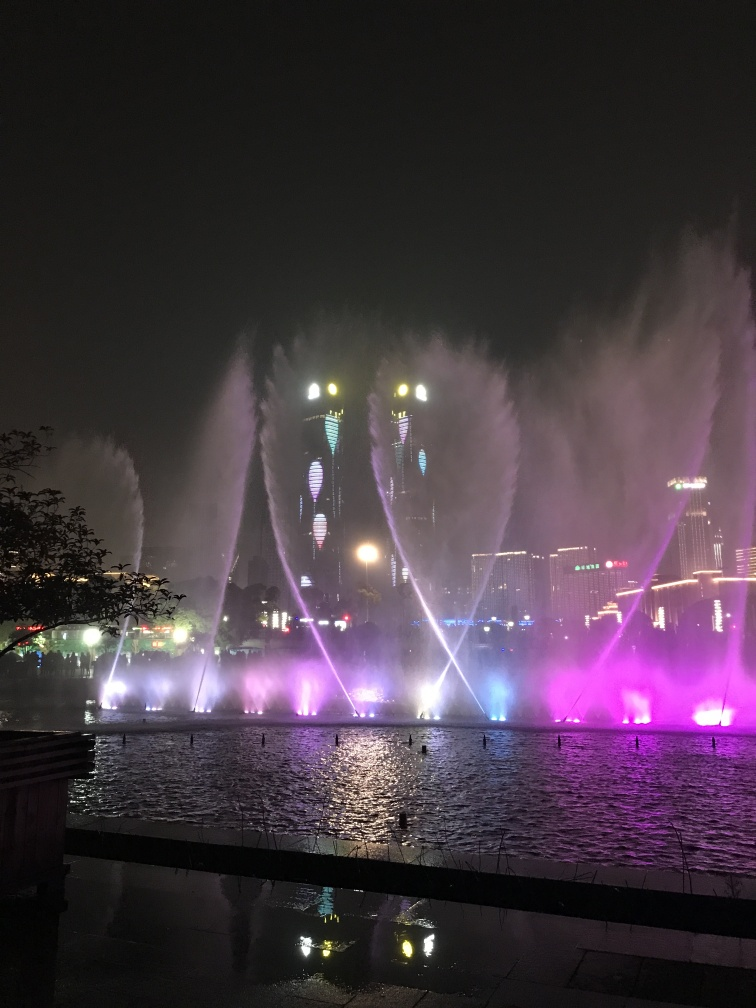Can you explain the mood set by this image? The image evokes a sense of wonder and vibrancy, largely due to the dynamic water fountains and the colorful light show. These elements contribute to a lively and enchanting atmosphere typically associated with nighttime cultural or entertainment events. 